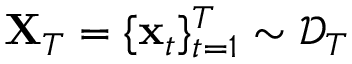<formula> <loc_0><loc_0><loc_500><loc_500>X _ { T } = \{ x _ { t } \} _ { t = 1 } ^ { T } \sim \mathcal { D } _ { T }</formula> 